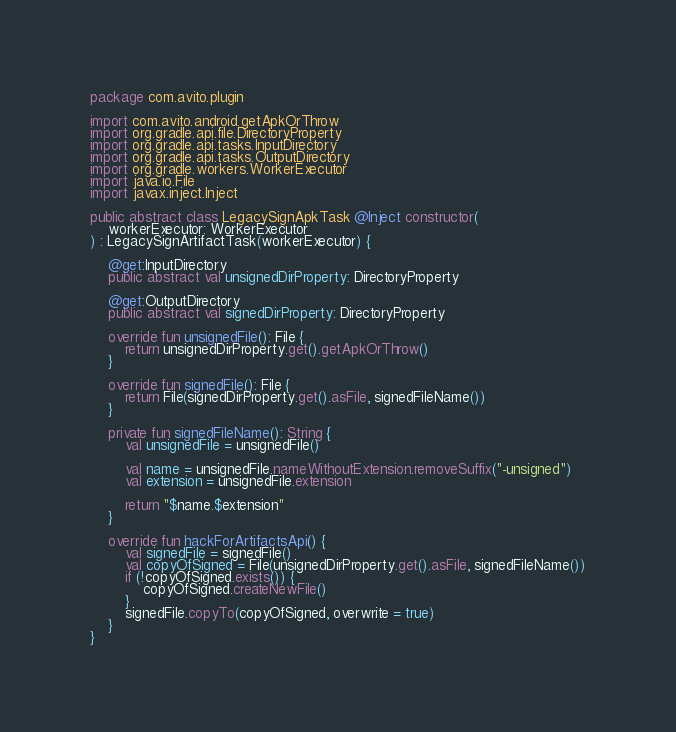Convert code to text. <code><loc_0><loc_0><loc_500><loc_500><_Kotlin_>package com.avito.plugin

import com.avito.android.getApkOrThrow
import org.gradle.api.file.DirectoryProperty
import org.gradle.api.tasks.InputDirectory
import org.gradle.api.tasks.OutputDirectory
import org.gradle.workers.WorkerExecutor
import java.io.File
import javax.inject.Inject

public abstract class LegacySignApkTask @Inject constructor(
    workerExecutor: WorkerExecutor
) : LegacySignArtifactTask(workerExecutor) {

    @get:InputDirectory
    public abstract val unsignedDirProperty: DirectoryProperty

    @get:OutputDirectory
    public abstract val signedDirProperty: DirectoryProperty

    override fun unsignedFile(): File {
        return unsignedDirProperty.get().getApkOrThrow()
    }

    override fun signedFile(): File {
        return File(signedDirProperty.get().asFile, signedFileName())
    }

    private fun signedFileName(): String {
        val unsignedFile = unsignedFile()

        val name = unsignedFile.nameWithoutExtension.removeSuffix("-unsigned")
        val extension = unsignedFile.extension

        return "$name.$extension"
    }

    override fun hackForArtifactsApi() {
        val signedFile = signedFile()
        val copyOfSigned = File(unsignedDirProperty.get().asFile, signedFileName())
        if (!copyOfSigned.exists()) {
            copyOfSigned.createNewFile()
        }
        signedFile.copyTo(copyOfSigned, overwrite = true)
    }
}
</code> 